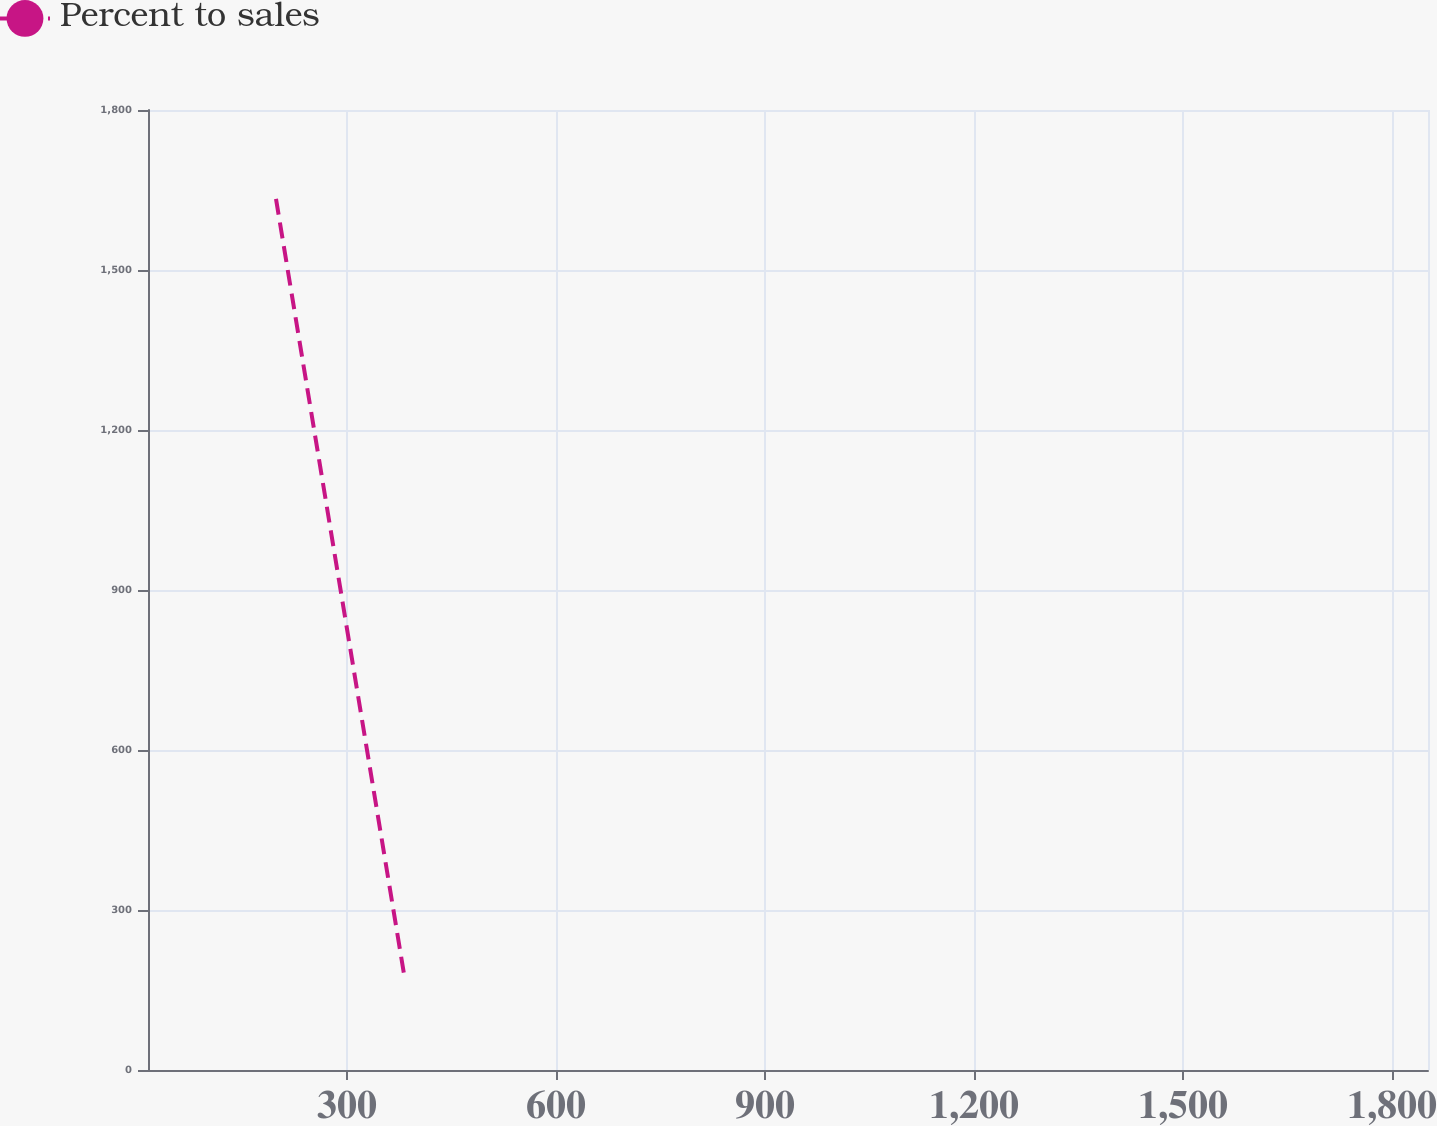<chart> <loc_0><loc_0><loc_500><loc_500><line_chart><ecel><fcel>Percent to sales<nl><fcel>198.23<fcel>1633.25<nl><fcel>381.93<fcel>179.92<nl><fcel>2035.21<fcel>18.44<nl></chart> 